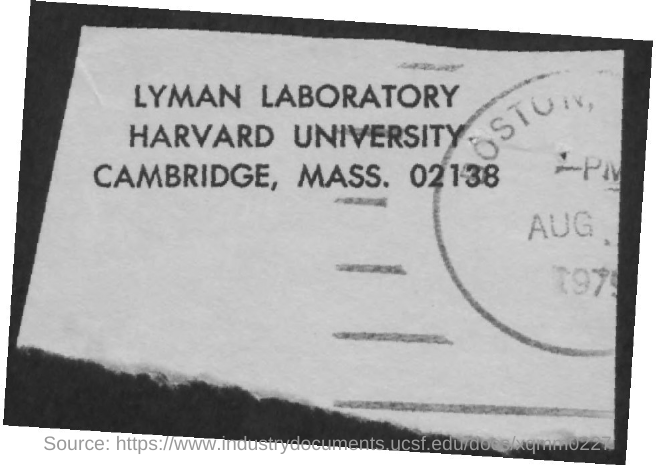Highlight a few significant elements in this photo. The postal address mentions Harvard University. 